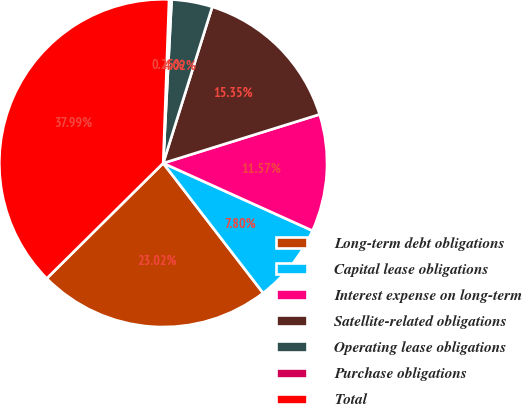Convert chart to OTSL. <chart><loc_0><loc_0><loc_500><loc_500><pie_chart><fcel>Long-term debt obligations<fcel>Capital lease obligations<fcel>Interest expense on long-term<fcel>Satellite-related obligations<fcel>Operating lease obligations<fcel>Purchase obligations<fcel>Total<nl><fcel>23.02%<fcel>7.8%<fcel>11.57%<fcel>15.35%<fcel>4.02%<fcel>0.25%<fcel>37.99%<nl></chart> 